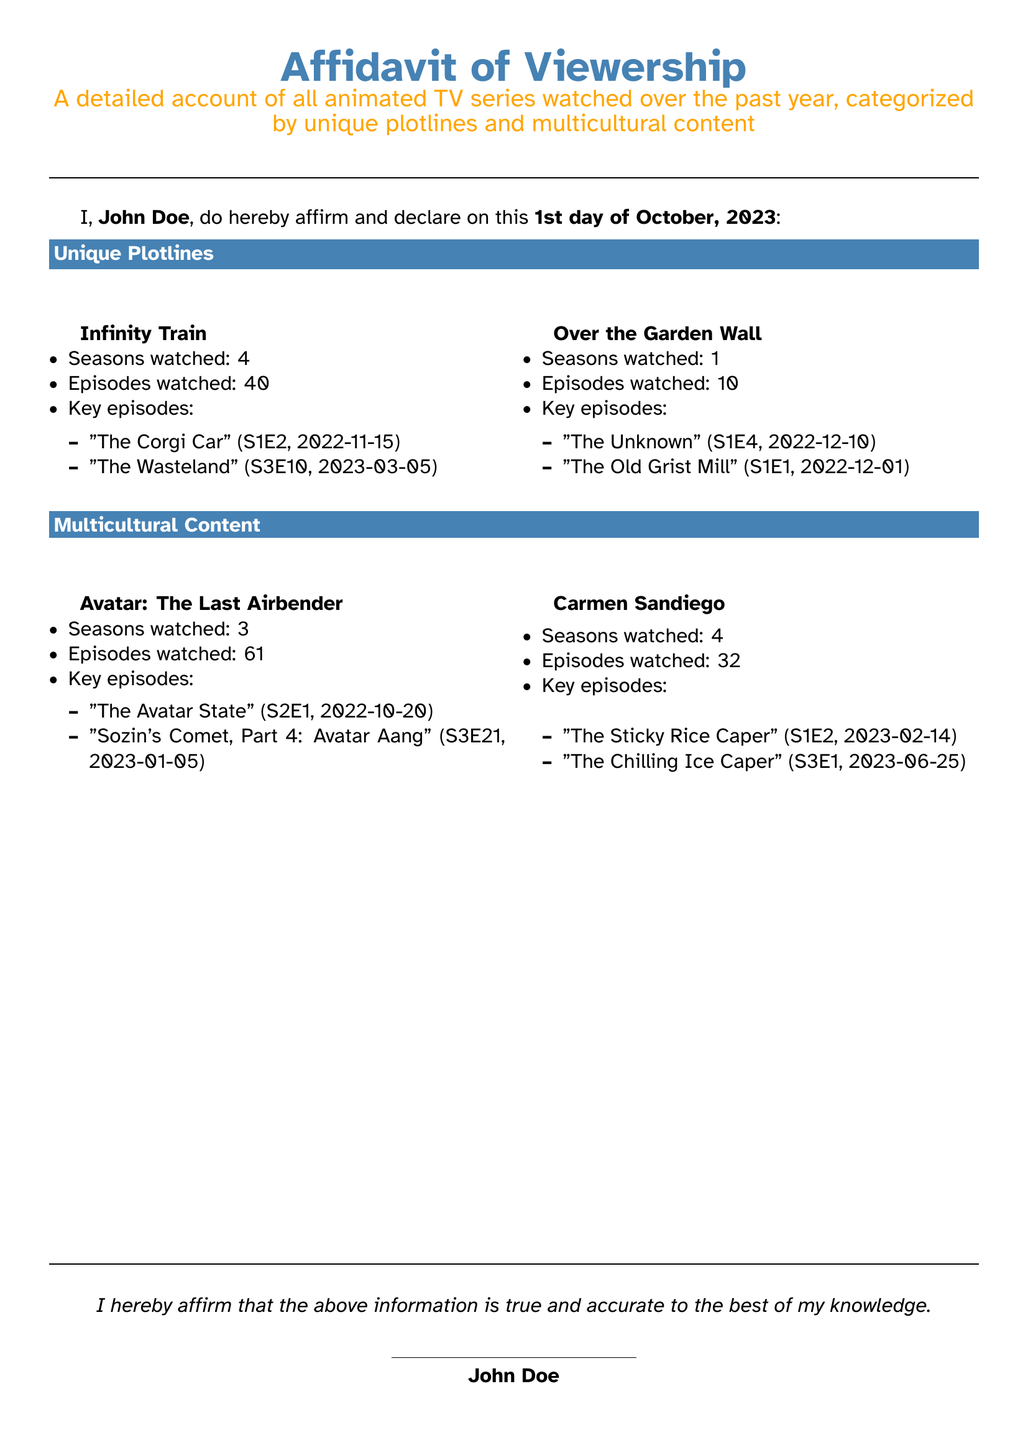What is the name of the person affirming the content? The document states that John Doe is the person affirming and declaring the content of the affidavit.
Answer: John Doe How many seasons of "Avatar: The Last Airbender" were watched? The document specifies that 3 seasons of "Avatar: The Last Airbender" were watched.
Answer: 3 What is the date of the key episode "The Corgi Car"? The document lists "The Corgi Car" with a viewing date of 2022-11-15.
Answer: 2022-11-15 How many episodes of "Carmen Sandiego" were watched? The document indicates that 32 episodes of "Carmen Sandiego" were viewed.
Answer: 32 Which show has the most episodes watched according to the document? By comparing the episode counts, it is clear that "Avatar: The Last Airbender" has the highest at 61 episodes.
Answer: Avatar: The Last Airbender What is the total number of key episodes documented for "Infinity Train"? The document lists two key episodes under "Infinity Train," meaning two key episodes are documented.
Answer: 2 What genre do all series listed in the affidavit belong to? The document mentions that the affidavit accounts for animated TV series, indicating the genre.
Answer: Animated On what date was the affidavit signed? The document specifies the signing date as the 1st day of October, 2023.
Answer: 1st day of October, 2023 Which show features multicultural content? The document lists "Carmen Sandiego" as one of the shows with multicultural content.
Answer: Carmen Sandiego 